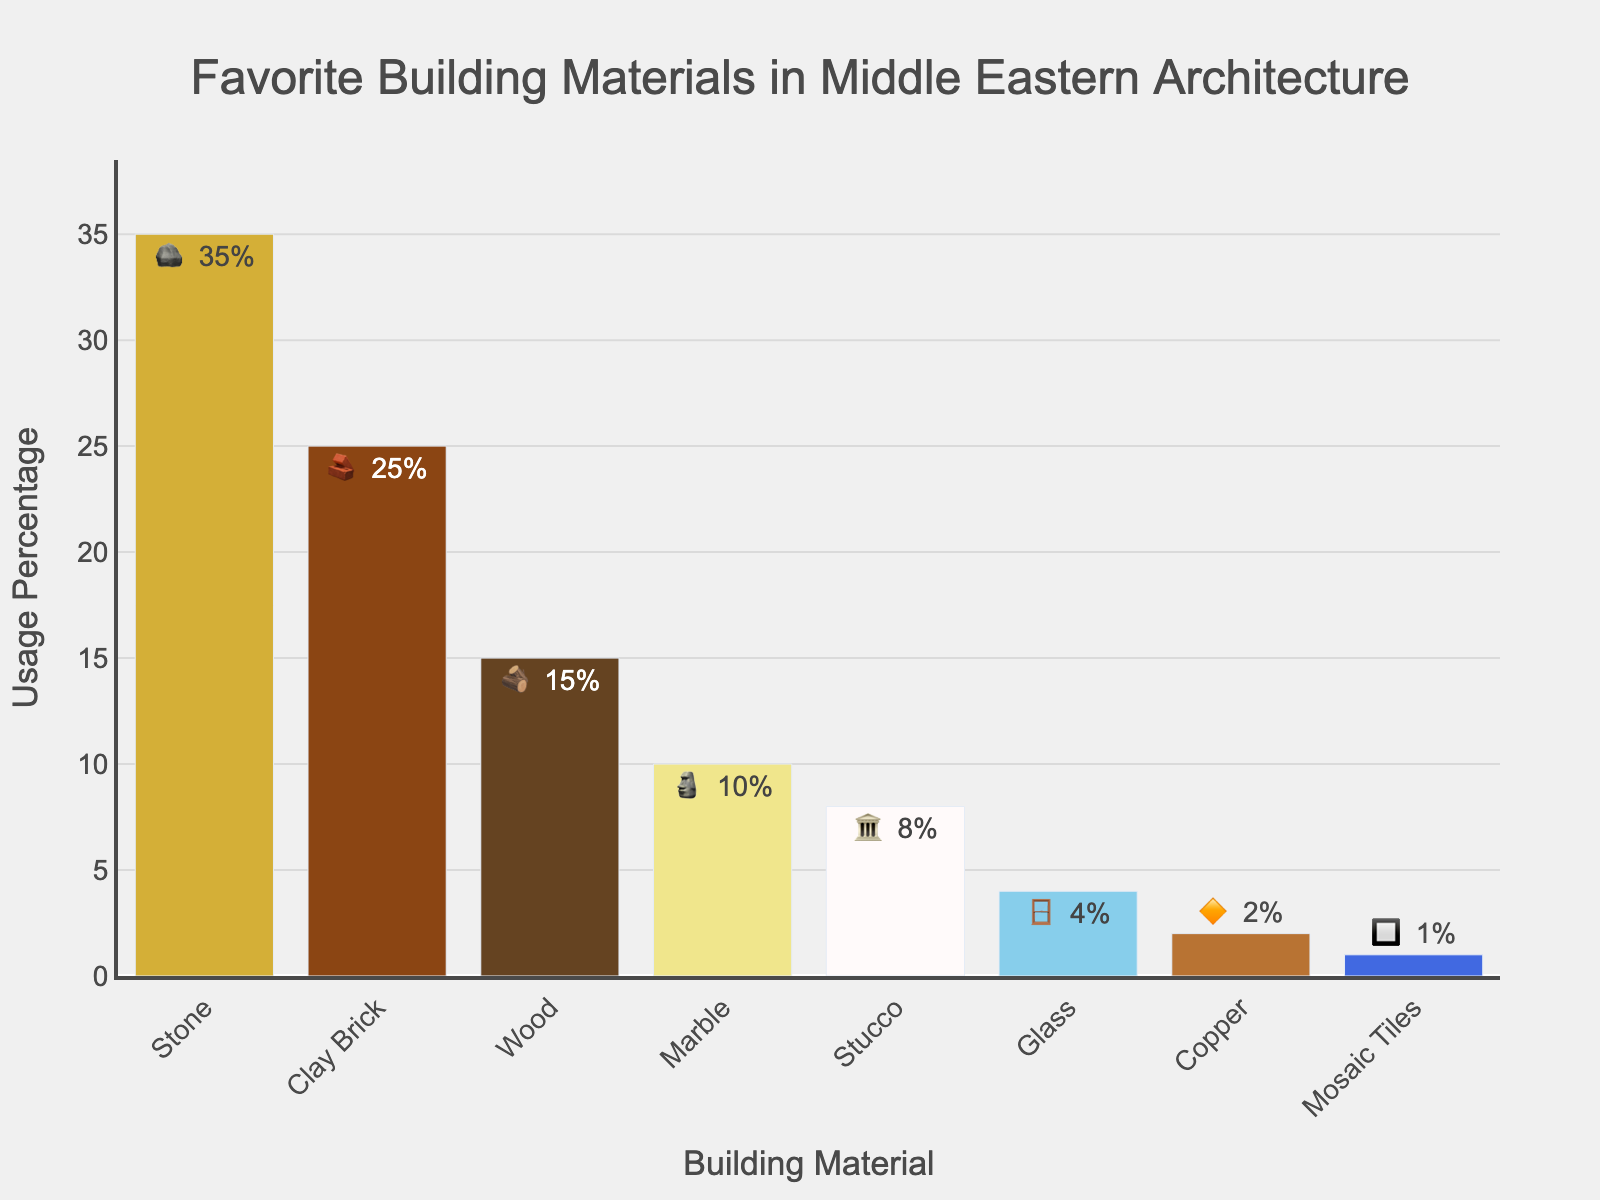Which building material is used the most in Middle Eastern architecture? Look at the bar chart and identify the material with the highest usage percentage. The tallest bar represents Stone at 35%.
Answer: Stone Which building materials use less than 5%? Look at the percentages on the bars and identify which ones are below 5%. The materials are Glass (4%), Copper (2%), and Mosaic Tiles (1%).
Answer: Glass, Copper, Mosaic Tiles What is the combined usage percentage of Marble and Stucco? Find the percentages for Marble (10%) and Stucco (8%) and add them together. 10% + 8% = 18%.
Answer: 18% Which material has a higher usage, Wood or Clay Brick? Compare the percentages of Wood (15%) and Clay Brick (25%). Clay Brick has a higher usage.
Answer: Clay Brick What percentage difference is there between the usage of Stone and Mosaic Tiles? Subtract the usage percentage of Mosaic Tiles (1%) from that of Stone (35%). 35% - 1% = 34%.
Answer: 34% How many building materials have a usage percentage greater than 10%? Count the bars with percentages greater than 10%. They are Stone (35%), Clay Brick (25%), and Wood (15%), a total of 3 materials.
Answer: 3 Which building material is represented by the emoji 🏛️? Find the emoji next to the percentage for each material in the bar chart. Stucco is represented by the 🏛️ emoji.
Answer: Stucco Which material has the smallest usage percentage? Look at the bar chart and identify the shortest bar. The smallest usage percentage belongs to Mosaic Tiles at 1%.
Answer: Mosaic Tiles 